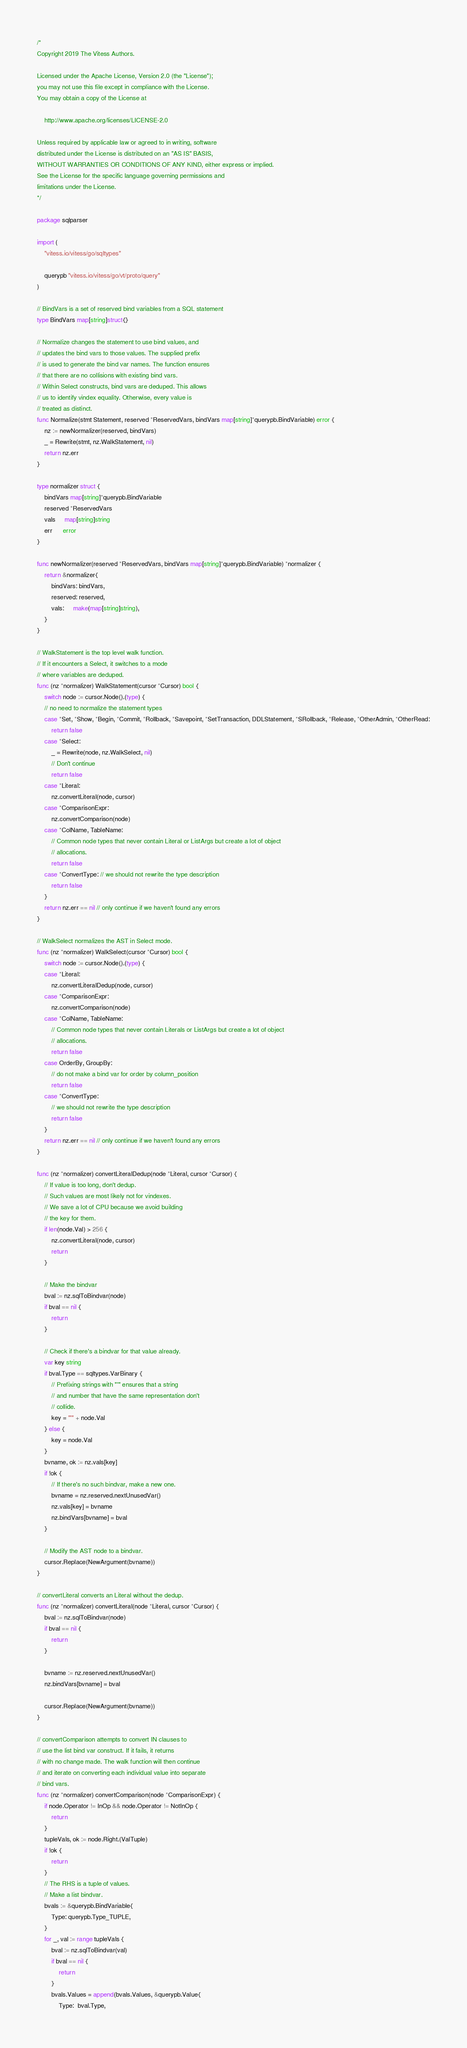<code> <loc_0><loc_0><loc_500><loc_500><_Go_>/*
Copyright 2019 The Vitess Authors.

Licensed under the Apache License, Version 2.0 (the "License");
you may not use this file except in compliance with the License.
You may obtain a copy of the License at

    http://www.apache.org/licenses/LICENSE-2.0

Unless required by applicable law or agreed to in writing, software
distributed under the License is distributed on an "AS IS" BASIS,
WITHOUT WARRANTIES OR CONDITIONS OF ANY KIND, either express or implied.
See the License for the specific language governing permissions and
limitations under the License.
*/

package sqlparser

import (
	"vitess.io/vitess/go/sqltypes"

	querypb "vitess.io/vitess/go/vt/proto/query"
)

// BindVars is a set of reserved bind variables from a SQL statement
type BindVars map[string]struct{}

// Normalize changes the statement to use bind values, and
// updates the bind vars to those values. The supplied prefix
// is used to generate the bind var names. The function ensures
// that there are no collisions with existing bind vars.
// Within Select constructs, bind vars are deduped. This allows
// us to identify vindex equality. Otherwise, every value is
// treated as distinct.
func Normalize(stmt Statement, reserved *ReservedVars, bindVars map[string]*querypb.BindVariable) error {
	nz := newNormalizer(reserved, bindVars)
	_ = Rewrite(stmt, nz.WalkStatement, nil)
	return nz.err
}

type normalizer struct {
	bindVars map[string]*querypb.BindVariable
	reserved *ReservedVars
	vals     map[string]string
	err      error
}

func newNormalizer(reserved *ReservedVars, bindVars map[string]*querypb.BindVariable) *normalizer {
	return &normalizer{
		bindVars: bindVars,
		reserved: reserved,
		vals:     make(map[string]string),
	}
}

// WalkStatement is the top level walk function.
// If it encounters a Select, it switches to a mode
// where variables are deduped.
func (nz *normalizer) WalkStatement(cursor *Cursor) bool {
	switch node := cursor.Node().(type) {
	// no need to normalize the statement types
	case *Set, *Show, *Begin, *Commit, *Rollback, *Savepoint, *SetTransaction, DDLStatement, *SRollback, *Release, *OtherAdmin, *OtherRead:
		return false
	case *Select:
		_ = Rewrite(node, nz.WalkSelect, nil)
		// Don't continue
		return false
	case *Literal:
		nz.convertLiteral(node, cursor)
	case *ComparisonExpr:
		nz.convertComparison(node)
	case *ColName, TableName:
		// Common node types that never contain Literal or ListArgs but create a lot of object
		// allocations.
		return false
	case *ConvertType: // we should not rewrite the type description
		return false
	}
	return nz.err == nil // only continue if we haven't found any errors
}

// WalkSelect normalizes the AST in Select mode.
func (nz *normalizer) WalkSelect(cursor *Cursor) bool {
	switch node := cursor.Node().(type) {
	case *Literal:
		nz.convertLiteralDedup(node, cursor)
	case *ComparisonExpr:
		nz.convertComparison(node)
	case *ColName, TableName:
		// Common node types that never contain Literals or ListArgs but create a lot of object
		// allocations.
		return false
	case OrderBy, GroupBy:
		// do not make a bind var for order by column_position
		return false
	case *ConvertType:
		// we should not rewrite the type description
		return false
	}
	return nz.err == nil // only continue if we haven't found any errors
}

func (nz *normalizer) convertLiteralDedup(node *Literal, cursor *Cursor) {
	// If value is too long, don't dedup.
	// Such values are most likely not for vindexes.
	// We save a lot of CPU because we avoid building
	// the key for them.
	if len(node.Val) > 256 {
		nz.convertLiteral(node, cursor)
		return
	}

	// Make the bindvar
	bval := nz.sqlToBindvar(node)
	if bval == nil {
		return
	}

	// Check if there's a bindvar for that value already.
	var key string
	if bval.Type == sqltypes.VarBinary {
		// Prefixing strings with "'" ensures that a string
		// and number that have the same representation don't
		// collide.
		key = "'" + node.Val
	} else {
		key = node.Val
	}
	bvname, ok := nz.vals[key]
	if !ok {
		// If there's no such bindvar, make a new one.
		bvname = nz.reserved.nextUnusedVar()
		nz.vals[key] = bvname
		nz.bindVars[bvname] = bval
	}

	// Modify the AST node to a bindvar.
	cursor.Replace(NewArgument(bvname))
}

// convertLiteral converts an Literal without the dedup.
func (nz *normalizer) convertLiteral(node *Literal, cursor *Cursor) {
	bval := nz.sqlToBindvar(node)
	if bval == nil {
		return
	}

	bvname := nz.reserved.nextUnusedVar()
	nz.bindVars[bvname] = bval

	cursor.Replace(NewArgument(bvname))
}

// convertComparison attempts to convert IN clauses to
// use the list bind var construct. If it fails, it returns
// with no change made. The walk function will then continue
// and iterate on converting each individual value into separate
// bind vars.
func (nz *normalizer) convertComparison(node *ComparisonExpr) {
	if node.Operator != InOp && node.Operator != NotInOp {
		return
	}
	tupleVals, ok := node.Right.(ValTuple)
	if !ok {
		return
	}
	// The RHS is a tuple of values.
	// Make a list bindvar.
	bvals := &querypb.BindVariable{
		Type: querypb.Type_TUPLE,
	}
	for _, val := range tupleVals {
		bval := nz.sqlToBindvar(val)
		if bval == nil {
			return
		}
		bvals.Values = append(bvals.Values, &querypb.Value{
			Type:  bval.Type,</code> 